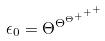<formula> <loc_0><loc_0><loc_500><loc_500>\epsilon _ { 0 } = \Theta ^ { \Theta ^ { \Theta ^ { + ^ { + ^ { + } } } } }</formula> 